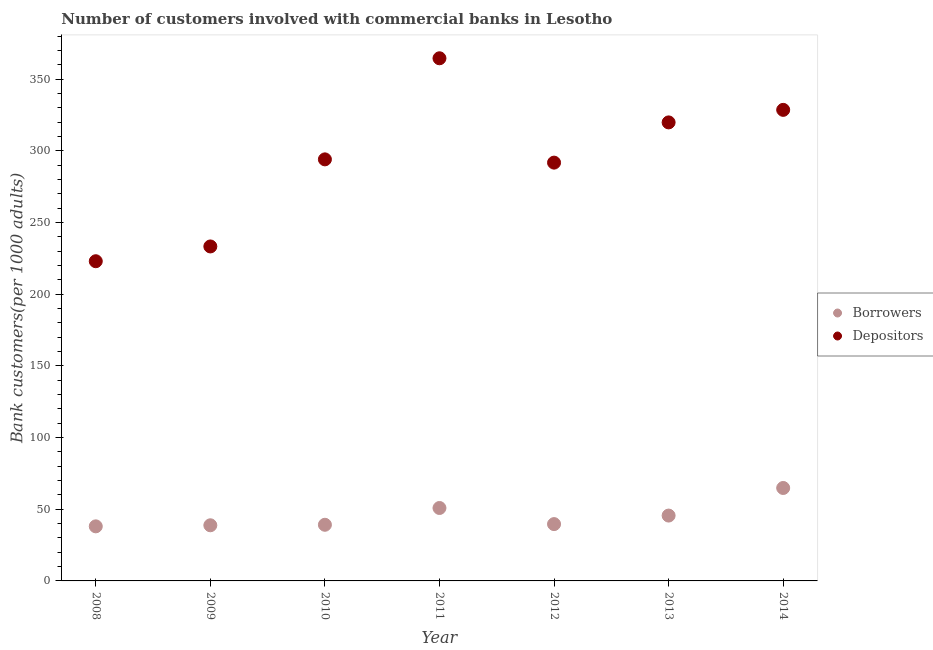What is the number of depositors in 2009?
Offer a very short reply. 233.31. Across all years, what is the maximum number of depositors?
Provide a short and direct response. 364.57. Across all years, what is the minimum number of borrowers?
Offer a terse response. 38.07. In which year was the number of borrowers maximum?
Offer a terse response. 2014. In which year was the number of borrowers minimum?
Offer a very short reply. 2008. What is the total number of borrowers in the graph?
Your answer should be very brief. 316.96. What is the difference between the number of depositors in 2008 and that in 2012?
Provide a short and direct response. -68.78. What is the difference between the number of depositors in 2011 and the number of borrowers in 2014?
Your answer should be compact. 299.74. What is the average number of depositors per year?
Your response must be concise. 293.59. In the year 2009, what is the difference between the number of depositors and number of borrowers?
Your answer should be compact. 194.5. What is the ratio of the number of depositors in 2008 to that in 2011?
Provide a succinct answer. 0.61. What is the difference between the highest and the second highest number of borrowers?
Keep it short and to the point. 13.96. What is the difference between the highest and the lowest number of depositors?
Provide a succinct answer. 141.56. In how many years, is the number of borrowers greater than the average number of borrowers taken over all years?
Your answer should be very brief. 3. Is the sum of the number of depositors in 2008 and 2009 greater than the maximum number of borrowers across all years?
Keep it short and to the point. Yes. Is the number of depositors strictly less than the number of borrowers over the years?
Give a very brief answer. No. How many dotlines are there?
Ensure brevity in your answer.  2. What is the difference between two consecutive major ticks on the Y-axis?
Keep it short and to the point. 50. Does the graph contain any zero values?
Keep it short and to the point. No. Does the graph contain grids?
Provide a succinct answer. No. How many legend labels are there?
Offer a very short reply. 2. What is the title of the graph?
Offer a terse response. Number of customers involved with commercial banks in Lesotho. What is the label or title of the X-axis?
Provide a succinct answer. Year. What is the label or title of the Y-axis?
Your answer should be compact. Bank customers(per 1000 adults). What is the Bank customers(per 1000 adults) in Borrowers in 2008?
Offer a very short reply. 38.07. What is the Bank customers(per 1000 adults) of Depositors in 2008?
Ensure brevity in your answer.  223. What is the Bank customers(per 1000 adults) of Borrowers in 2009?
Your answer should be very brief. 38.81. What is the Bank customers(per 1000 adults) in Depositors in 2009?
Give a very brief answer. 233.31. What is the Bank customers(per 1000 adults) in Borrowers in 2010?
Your response must be concise. 39.16. What is the Bank customers(per 1000 adults) in Depositors in 2010?
Your answer should be very brief. 294.05. What is the Bank customers(per 1000 adults) in Borrowers in 2011?
Offer a very short reply. 50.87. What is the Bank customers(per 1000 adults) in Depositors in 2011?
Ensure brevity in your answer.  364.57. What is the Bank customers(per 1000 adults) of Borrowers in 2012?
Provide a succinct answer. 39.63. What is the Bank customers(per 1000 adults) of Depositors in 2012?
Ensure brevity in your answer.  291.78. What is the Bank customers(per 1000 adults) of Borrowers in 2013?
Keep it short and to the point. 45.58. What is the Bank customers(per 1000 adults) in Depositors in 2013?
Make the answer very short. 319.84. What is the Bank customers(per 1000 adults) of Borrowers in 2014?
Ensure brevity in your answer.  64.83. What is the Bank customers(per 1000 adults) of Depositors in 2014?
Make the answer very short. 328.59. Across all years, what is the maximum Bank customers(per 1000 adults) in Borrowers?
Keep it short and to the point. 64.83. Across all years, what is the maximum Bank customers(per 1000 adults) of Depositors?
Make the answer very short. 364.57. Across all years, what is the minimum Bank customers(per 1000 adults) of Borrowers?
Your response must be concise. 38.07. Across all years, what is the minimum Bank customers(per 1000 adults) of Depositors?
Provide a short and direct response. 223. What is the total Bank customers(per 1000 adults) of Borrowers in the graph?
Offer a terse response. 316.96. What is the total Bank customers(per 1000 adults) in Depositors in the graph?
Provide a succinct answer. 2055.14. What is the difference between the Bank customers(per 1000 adults) in Borrowers in 2008 and that in 2009?
Ensure brevity in your answer.  -0.74. What is the difference between the Bank customers(per 1000 adults) of Depositors in 2008 and that in 2009?
Ensure brevity in your answer.  -10.3. What is the difference between the Bank customers(per 1000 adults) of Borrowers in 2008 and that in 2010?
Ensure brevity in your answer.  -1.09. What is the difference between the Bank customers(per 1000 adults) in Depositors in 2008 and that in 2010?
Your answer should be compact. -71.05. What is the difference between the Bank customers(per 1000 adults) of Borrowers in 2008 and that in 2011?
Ensure brevity in your answer.  -12.8. What is the difference between the Bank customers(per 1000 adults) of Depositors in 2008 and that in 2011?
Your answer should be very brief. -141.56. What is the difference between the Bank customers(per 1000 adults) of Borrowers in 2008 and that in 2012?
Your answer should be very brief. -1.56. What is the difference between the Bank customers(per 1000 adults) in Depositors in 2008 and that in 2012?
Ensure brevity in your answer.  -68.78. What is the difference between the Bank customers(per 1000 adults) in Borrowers in 2008 and that in 2013?
Offer a terse response. -7.51. What is the difference between the Bank customers(per 1000 adults) of Depositors in 2008 and that in 2013?
Offer a very short reply. -96.84. What is the difference between the Bank customers(per 1000 adults) of Borrowers in 2008 and that in 2014?
Your response must be concise. -26.76. What is the difference between the Bank customers(per 1000 adults) in Depositors in 2008 and that in 2014?
Provide a short and direct response. -105.58. What is the difference between the Bank customers(per 1000 adults) of Borrowers in 2009 and that in 2010?
Provide a short and direct response. -0.35. What is the difference between the Bank customers(per 1000 adults) of Depositors in 2009 and that in 2010?
Provide a succinct answer. -60.75. What is the difference between the Bank customers(per 1000 adults) in Borrowers in 2009 and that in 2011?
Your response must be concise. -12.06. What is the difference between the Bank customers(per 1000 adults) in Depositors in 2009 and that in 2011?
Your answer should be compact. -131.26. What is the difference between the Bank customers(per 1000 adults) in Borrowers in 2009 and that in 2012?
Ensure brevity in your answer.  -0.82. What is the difference between the Bank customers(per 1000 adults) in Depositors in 2009 and that in 2012?
Offer a very short reply. -58.47. What is the difference between the Bank customers(per 1000 adults) of Borrowers in 2009 and that in 2013?
Offer a very short reply. -6.78. What is the difference between the Bank customers(per 1000 adults) of Depositors in 2009 and that in 2013?
Give a very brief answer. -86.53. What is the difference between the Bank customers(per 1000 adults) of Borrowers in 2009 and that in 2014?
Offer a very short reply. -26.02. What is the difference between the Bank customers(per 1000 adults) of Depositors in 2009 and that in 2014?
Offer a very short reply. -95.28. What is the difference between the Bank customers(per 1000 adults) in Borrowers in 2010 and that in 2011?
Your answer should be compact. -11.71. What is the difference between the Bank customers(per 1000 adults) of Depositors in 2010 and that in 2011?
Make the answer very short. -70.51. What is the difference between the Bank customers(per 1000 adults) of Borrowers in 2010 and that in 2012?
Your answer should be very brief. -0.47. What is the difference between the Bank customers(per 1000 adults) of Depositors in 2010 and that in 2012?
Ensure brevity in your answer.  2.27. What is the difference between the Bank customers(per 1000 adults) in Borrowers in 2010 and that in 2013?
Provide a succinct answer. -6.42. What is the difference between the Bank customers(per 1000 adults) of Depositors in 2010 and that in 2013?
Your answer should be very brief. -25.79. What is the difference between the Bank customers(per 1000 adults) in Borrowers in 2010 and that in 2014?
Offer a very short reply. -25.67. What is the difference between the Bank customers(per 1000 adults) of Depositors in 2010 and that in 2014?
Make the answer very short. -34.53. What is the difference between the Bank customers(per 1000 adults) of Borrowers in 2011 and that in 2012?
Keep it short and to the point. 11.24. What is the difference between the Bank customers(per 1000 adults) of Depositors in 2011 and that in 2012?
Your response must be concise. 72.79. What is the difference between the Bank customers(per 1000 adults) in Borrowers in 2011 and that in 2013?
Make the answer very short. 5.29. What is the difference between the Bank customers(per 1000 adults) in Depositors in 2011 and that in 2013?
Keep it short and to the point. 44.73. What is the difference between the Bank customers(per 1000 adults) in Borrowers in 2011 and that in 2014?
Ensure brevity in your answer.  -13.96. What is the difference between the Bank customers(per 1000 adults) of Depositors in 2011 and that in 2014?
Make the answer very short. 35.98. What is the difference between the Bank customers(per 1000 adults) in Borrowers in 2012 and that in 2013?
Give a very brief answer. -5.95. What is the difference between the Bank customers(per 1000 adults) in Depositors in 2012 and that in 2013?
Your response must be concise. -28.06. What is the difference between the Bank customers(per 1000 adults) of Borrowers in 2012 and that in 2014?
Offer a terse response. -25.2. What is the difference between the Bank customers(per 1000 adults) in Depositors in 2012 and that in 2014?
Your answer should be very brief. -36.8. What is the difference between the Bank customers(per 1000 adults) in Borrowers in 2013 and that in 2014?
Your answer should be compact. -19.24. What is the difference between the Bank customers(per 1000 adults) in Depositors in 2013 and that in 2014?
Keep it short and to the point. -8.74. What is the difference between the Bank customers(per 1000 adults) of Borrowers in 2008 and the Bank customers(per 1000 adults) of Depositors in 2009?
Your answer should be compact. -195.24. What is the difference between the Bank customers(per 1000 adults) in Borrowers in 2008 and the Bank customers(per 1000 adults) in Depositors in 2010?
Make the answer very short. -255.98. What is the difference between the Bank customers(per 1000 adults) of Borrowers in 2008 and the Bank customers(per 1000 adults) of Depositors in 2011?
Offer a very short reply. -326.5. What is the difference between the Bank customers(per 1000 adults) in Borrowers in 2008 and the Bank customers(per 1000 adults) in Depositors in 2012?
Give a very brief answer. -253.71. What is the difference between the Bank customers(per 1000 adults) of Borrowers in 2008 and the Bank customers(per 1000 adults) of Depositors in 2013?
Your answer should be compact. -281.77. What is the difference between the Bank customers(per 1000 adults) in Borrowers in 2008 and the Bank customers(per 1000 adults) in Depositors in 2014?
Ensure brevity in your answer.  -290.51. What is the difference between the Bank customers(per 1000 adults) of Borrowers in 2009 and the Bank customers(per 1000 adults) of Depositors in 2010?
Provide a short and direct response. -255.24. What is the difference between the Bank customers(per 1000 adults) in Borrowers in 2009 and the Bank customers(per 1000 adults) in Depositors in 2011?
Your answer should be very brief. -325.76. What is the difference between the Bank customers(per 1000 adults) of Borrowers in 2009 and the Bank customers(per 1000 adults) of Depositors in 2012?
Your answer should be very brief. -252.97. What is the difference between the Bank customers(per 1000 adults) of Borrowers in 2009 and the Bank customers(per 1000 adults) of Depositors in 2013?
Your answer should be very brief. -281.03. What is the difference between the Bank customers(per 1000 adults) of Borrowers in 2009 and the Bank customers(per 1000 adults) of Depositors in 2014?
Your answer should be very brief. -289.78. What is the difference between the Bank customers(per 1000 adults) in Borrowers in 2010 and the Bank customers(per 1000 adults) in Depositors in 2011?
Your answer should be very brief. -325.41. What is the difference between the Bank customers(per 1000 adults) of Borrowers in 2010 and the Bank customers(per 1000 adults) of Depositors in 2012?
Offer a terse response. -252.62. What is the difference between the Bank customers(per 1000 adults) of Borrowers in 2010 and the Bank customers(per 1000 adults) of Depositors in 2013?
Make the answer very short. -280.68. What is the difference between the Bank customers(per 1000 adults) of Borrowers in 2010 and the Bank customers(per 1000 adults) of Depositors in 2014?
Offer a terse response. -289.42. What is the difference between the Bank customers(per 1000 adults) of Borrowers in 2011 and the Bank customers(per 1000 adults) of Depositors in 2012?
Make the answer very short. -240.91. What is the difference between the Bank customers(per 1000 adults) of Borrowers in 2011 and the Bank customers(per 1000 adults) of Depositors in 2013?
Make the answer very short. -268.97. What is the difference between the Bank customers(per 1000 adults) of Borrowers in 2011 and the Bank customers(per 1000 adults) of Depositors in 2014?
Ensure brevity in your answer.  -277.71. What is the difference between the Bank customers(per 1000 adults) of Borrowers in 2012 and the Bank customers(per 1000 adults) of Depositors in 2013?
Make the answer very short. -280.21. What is the difference between the Bank customers(per 1000 adults) in Borrowers in 2012 and the Bank customers(per 1000 adults) in Depositors in 2014?
Ensure brevity in your answer.  -288.95. What is the difference between the Bank customers(per 1000 adults) of Borrowers in 2013 and the Bank customers(per 1000 adults) of Depositors in 2014?
Keep it short and to the point. -283. What is the average Bank customers(per 1000 adults) in Borrowers per year?
Give a very brief answer. 45.28. What is the average Bank customers(per 1000 adults) of Depositors per year?
Keep it short and to the point. 293.59. In the year 2008, what is the difference between the Bank customers(per 1000 adults) in Borrowers and Bank customers(per 1000 adults) in Depositors?
Provide a succinct answer. -184.93. In the year 2009, what is the difference between the Bank customers(per 1000 adults) of Borrowers and Bank customers(per 1000 adults) of Depositors?
Provide a short and direct response. -194.5. In the year 2010, what is the difference between the Bank customers(per 1000 adults) in Borrowers and Bank customers(per 1000 adults) in Depositors?
Give a very brief answer. -254.89. In the year 2011, what is the difference between the Bank customers(per 1000 adults) of Borrowers and Bank customers(per 1000 adults) of Depositors?
Provide a short and direct response. -313.7. In the year 2012, what is the difference between the Bank customers(per 1000 adults) in Borrowers and Bank customers(per 1000 adults) in Depositors?
Make the answer very short. -252.15. In the year 2013, what is the difference between the Bank customers(per 1000 adults) in Borrowers and Bank customers(per 1000 adults) in Depositors?
Offer a terse response. -274.26. In the year 2014, what is the difference between the Bank customers(per 1000 adults) in Borrowers and Bank customers(per 1000 adults) in Depositors?
Ensure brevity in your answer.  -263.76. What is the ratio of the Bank customers(per 1000 adults) in Borrowers in 2008 to that in 2009?
Keep it short and to the point. 0.98. What is the ratio of the Bank customers(per 1000 adults) of Depositors in 2008 to that in 2009?
Provide a succinct answer. 0.96. What is the ratio of the Bank customers(per 1000 adults) in Borrowers in 2008 to that in 2010?
Offer a terse response. 0.97. What is the ratio of the Bank customers(per 1000 adults) of Depositors in 2008 to that in 2010?
Ensure brevity in your answer.  0.76. What is the ratio of the Bank customers(per 1000 adults) in Borrowers in 2008 to that in 2011?
Your answer should be compact. 0.75. What is the ratio of the Bank customers(per 1000 adults) in Depositors in 2008 to that in 2011?
Your answer should be very brief. 0.61. What is the ratio of the Bank customers(per 1000 adults) in Borrowers in 2008 to that in 2012?
Provide a succinct answer. 0.96. What is the ratio of the Bank customers(per 1000 adults) in Depositors in 2008 to that in 2012?
Offer a terse response. 0.76. What is the ratio of the Bank customers(per 1000 adults) of Borrowers in 2008 to that in 2013?
Make the answer very short. 0.84. What is the ratio of the Bank customers(per 1000 adults) of Depositors in 2008 to that in 2013?
Your response must be concise. 0.7. What is the ratio of the Bank customers(per 1000 adults) of Borrowers in 2008 to that in 2014?
Offer a very short reply. 0.59. What is the ratio of the Bank customers(per 1000 adults) of Depositors in 2008 to that in 2014?
Your response must be concise. 0.68. What is the ratio of the Bank customers(per 1000 adults) of Depositors in 2009 to that in 2010?
Your response must be concise. 0.79. What is the ratio of the Bank customers(per 1000 adults) in Borrowers in 2009 to that in 2011?
Offer a terse response. 0.76. What is the ratio of the Bank customers(per 1000 adults) of Depositors in 2009 to that in 2011?
Offer a very short reply. 0.64. What is the ratio of the Bank customers(per 1000 adults) in Borrowers in 2009 to that in 2012?
Give a very brief answer. 0.98. What is the ratio of the Bank customers(per 1000 adults) of Depositors in 2009 to that in 2012?
Your answer should be compact. 0.8. What is the ratio of the Bank customers(per 1000 adults) in Borrowers in 2009 to that in 2013?
Your response must be concise. 0.85. What is the ratio of the Bank customers(per 1000 adults) in Depositors in 2009 to that in 2013?
Ensure brevity in your answer.  0.73. What is the ratio of the Bank customers(per 1000 adults) in Borrowers in 2009 to that in 2014?
Provide a short and direct response. 0.6. What is the ratio of the Bank customers(per 1000 adults) of Depositors in 2009 to that in 2014?
Provide a succinct answer. 0.71. What is the ratio of the Bank customers(per 1000 adults) in Borrowers in 2010 to that in 2011?
Make the answer very short. 0.77. What is the ratio of the Bank customers(per 1000 adults) in Depositors in 2010 to that in 2011?
Your response must be concise. 0.81. What is the ratio of the Bank customers(per 1000 adults) in Borrowers in 2010 to that in 2013?
Make the answer very short. 0.86. What is the ratio of the Bank customers(per 1000 adults) in Depositors in 2010 to that in 2013?
Offer a terse response. 0.92. What is the ratio of the Bank customers(per 1000 adults) in Borrowers in 2010 to that in 2014?
Make the answer very short. 0.6. What is the ratio of the Bank customers(per 1000 adults) in Depositors in 2010 to that in 2014?
Offer a very short reply. 0.89. What is the ratio of the Bank customers(per 1000 adults) of Borrowers in 2011 to that in 2012?
Give a very brief answer. 1.28. What is the ratio of the Bank customers(per 1000 adults) in Depositors in 2011 to that in 2012?
Ensure brevity in your answer.  1.25. What is the ratio of the Bank customers(per 1000 adults) in Borrowers in 2011 to that in 2013?
Keep it short and to the point. 1.12. What is the ratio of the Bank customers(per 1000 adults) of Depositors in 2011 to that in 2013?
Your response must be concise. 1.14. What is the ratio of the Bank customers(per 1000 adults) of Borrowers in 2011 to that in 2014?
Keep it short and to the point. 0.78. What is the ratio of the Bank customers(per 1000 adults) of Depositors in 2011 to that in 2014?
Keep it short and to the point. 1.11. What is the ratio of the Bank customers(per 1000 adults) in Borrowers in 2012 to that in 2013?
Your answer should be compact. 0.87. What is the ratio of the Bank customers(per 1000 adults) of Depositors in 2012 to that in 2013?
Your response must be concise. 0.91. What is the ratio of the Bank customers(per 1000 adults) in Borrowers in 2012 to that in 2014?
Provide a short and direct response. 0.61. What is the ratio of the Bank customers(per 1000 adults) in Depositors in 2012 to that in 2014?
Make the answer very short. 0.89. What is the ratio of the Bank customers(per 1000 adults) of Borrowers in 2013 to that in 2014?
Provide a succinct answer. 0.7. What is the ratio of the Bank customers(per 1000 adults) in Depositors in 2013 to that in 2014?
Offer a very short reply. 0.97. What is the difference between the highest and the second highest Bank customers(per 1000 adults) of Borrowers?
Your response must be concise. 13.96. What is the difference between the highest and the second highest Bank customers(per 1000 adults) of Depositors?
Make the answer very short. 35.98. What is the difference between the highest and the lowest Bank customers(per 1000 adults) in Borrowers?
Offer a very short reply. 26.76. What is the difference between the highest and the lowest Bank customers(per 1000 adults) in Depositors?
Make the answer very short. 141.56. 